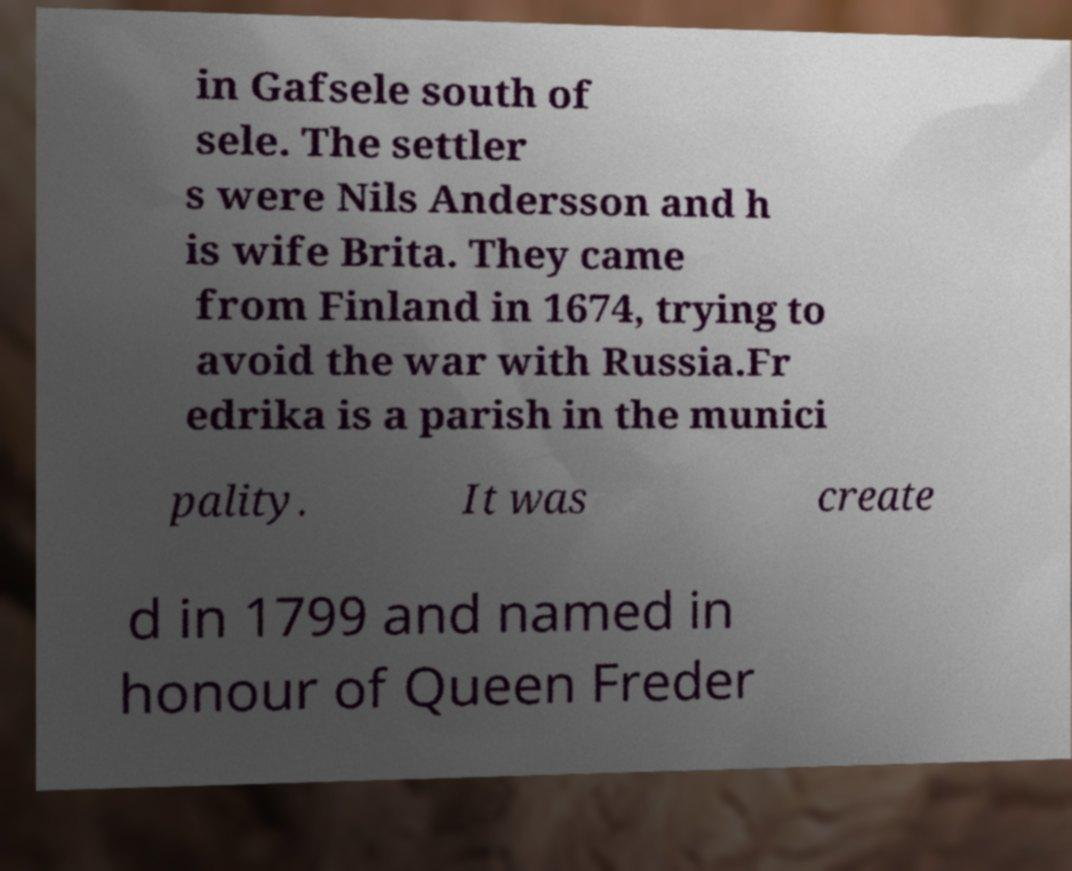Please identify and transcribe the text found in this image. in Gafsele south of sele. The settler s were Nils Andersson and h is wife Brita. They came from Finland in 1674, trying to avoid the war with Russia.Fr edrika is a parish in the munici pality. It was create d in 1799 and named in honour of Queen Freder 